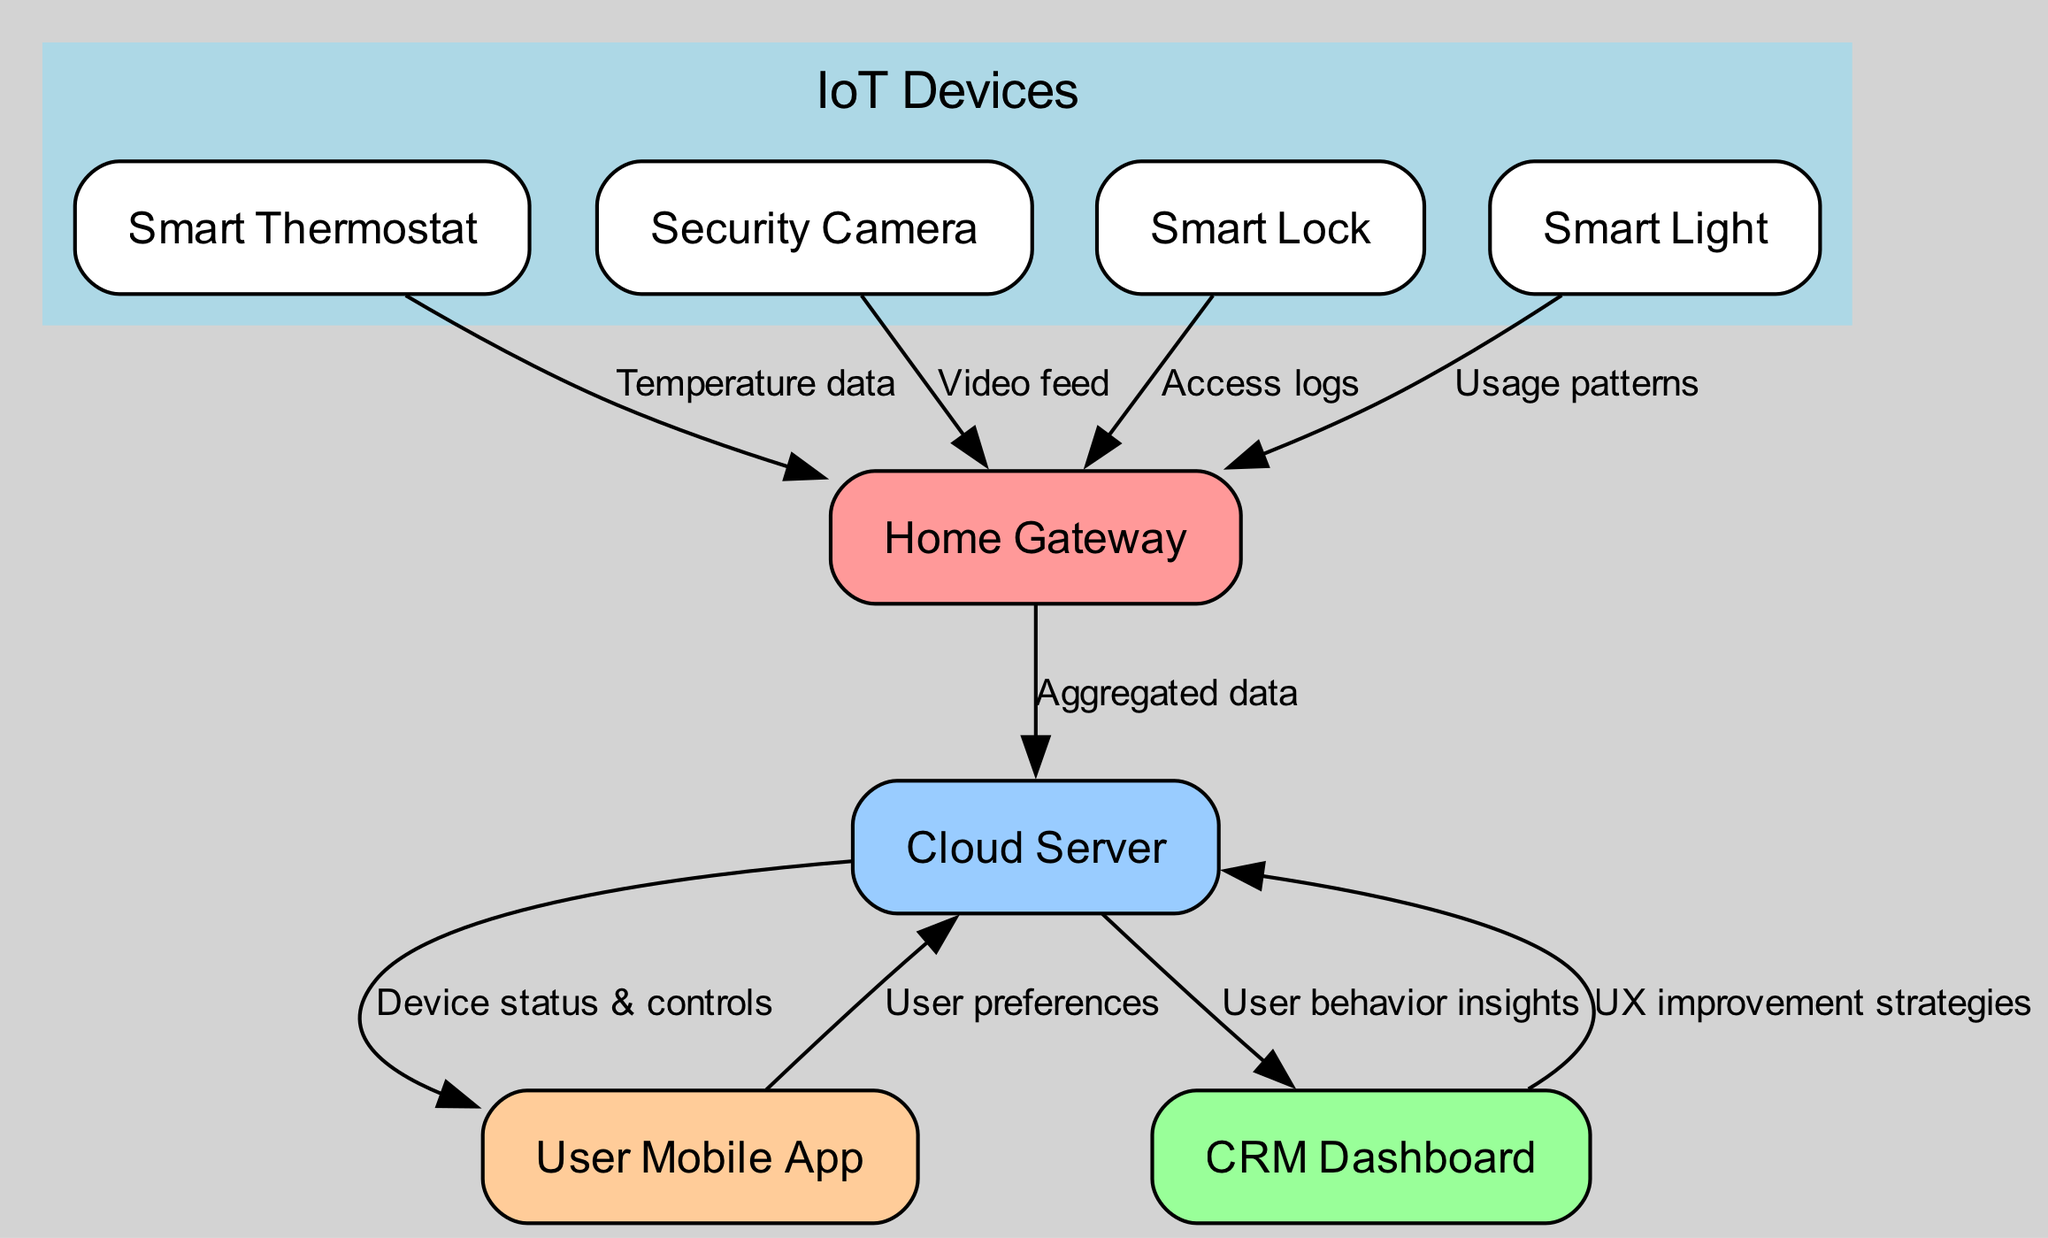What is the label of the node representing the data aggregator? The node that represents the data aggregator functions as an intermediary for devices and cloud storage. It is labeled "Home Gateway."
Answer: Home Gateway How many IoT devices are shown in the diagram? The diagram includes a dedicated cluster of IoT devices, and by counting the nodes within that cluster, we find four devices: Thermostat, Camera, Lock, and Light.
Answer: 4 What type of data flows from the Smart Thermostat to the Home Gateway? The relationship is specified by a labeled edge depicting the nature of the data being sent. The label indicates that the data being transferred is "Temperature data."
Answer: Temperature data From which node does the CRM Dashboard receive insights? An edge is directed from the Cloud Server to the CRM Dashboard, indicating the source of the insights as specified by the edge label "User behavior insights."
Answer: Cloud Server Which device collects access logs? The Smart Lock is explicitly mentioned as sending access logs to the Home Gateway according to the connecting edge labeled "Access logs."
Answer: Smart Lock How many types of data are being sent from the Cloud Server? Analyzing the outgoing edges from the Cloud Server shows two types of data being sent: "Device status & controls" to the User App and "User behavior insights" to the CRM Dashboard.
Answer: 2 What is the purpose of the arrow from the CRM Dashboard to the Cloud Server? The directed edge between these two nodes is labeled "UX improvement strategies," indicating that the dashboard communicates strategies based on user behavior and data.
Answer: UX improvement strategies Which node is connected to three other nodes via edges? The Home Gateway serves as a central hub receiving data from multiple devices, specifically indicating connections to the Smart Thermostat, Security Camera, Smart Lock, and Smart Light, making a total of four connections.
Answer: Home Gateway What data flows from the User Mobile App to the Cloud Server? The edge directed from the User Mobile App to the Cloud Server is labeled "User preferences," showing what information is being sent back to the cloud system.
Answer: User preferences 